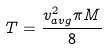<formula> <loc_0><loc_0><loc_500><loc_500>T = \frac { v _ { a v g } ^ { 2 } \pi M } { 8 }</formula> 